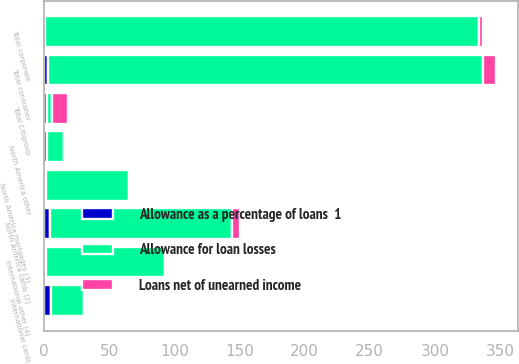<chart> <loc_0><loc_0><loc_500><loc_500><stacked_bar_chart><ecel><fcel>North America cards (2)<fcel>North America mortgages (3)<fcel>North America other<fcel>International cards<fcel>International other (4)<fcel>Total consumer<fcel>Total corporate<fcel>Total Citigroup<nl><fcel>Loans net of unearned income<fcel>6.1<fcel>0.7<fcel>0.3<fcel>1.3<fcel>1.5<fcel>9.9<fcel>2.5<fcel>12.4<nl><fcel>Allowance for loan losses<fcel>139.7<fcel>64.2<fcel>13<fcel>25.7<fcel>91.1<fcel>333.7<fcel>333.3<fcel>4.4<nl><fcel>Allowance as a percentage of loans  1<fcel>4.4<fcel>1.1<fcel>2.3<fcel>5.1<fcel>1.6<fcel>3<fcel>0.8<fcel>1.9<nl></chart> 